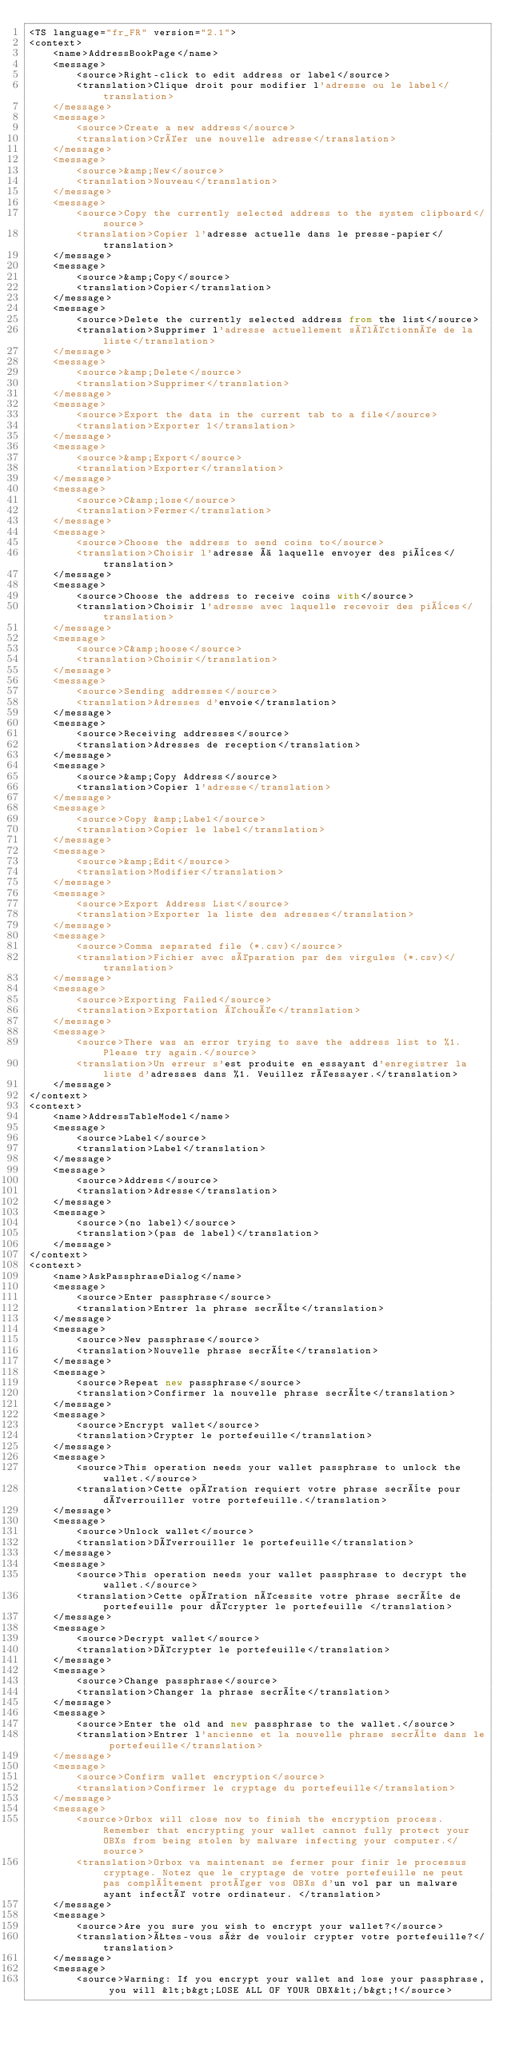<code> <loc_0><loc_0><loc_500><loc_500><_TypeScript_><TS language="fr_FR" version="2.1">
<context>
    <name>AddressBookPage</name>
    <message>
        <source>Right-click to edit address or label</source>
        <translation>Clique droit pour modifier l'adresse ou le label</translation>
    </message>
    <message>
        <source>Create a new address</source>
        <translation>Créer une nouvelle adresse</translation>
    </message>
    <message>
        <source>&amp;New</source>
        <translation>Nouveau</translation>
    </message>
    <message>
        <source>Copy the currently selected address to the system clipboard</source>
        <translation>Copier l'adresse actuelle dans le presse-papier</translation>
    </message>
    <message>
        <source>&amp;Copy</source>
        <translation>Copier</translation>
    </message>
    <message>
        <source>Delete the currently selected address from the list</source>
        <translation>Supprimer l'adresse actuellement séléctionnée de la liste</translation>
    </message>
    <message>
        <source>&amp;Delete</source>
        <translation>Supprimer</translation>
    </message>
    <message>
        <source>Export the data in the current tab to a file</source>
        <translation>Exporter l</translation>
    </message>
    <message>
        <source>&amp;Export</source>
        <translation>Exporter</translation>
    </message>
    <message>
        <source>C&amp;lose</source>
        <translation>Fermer</translation>
    </message>
    <message>
        <source>Choose the address to send coins to</source>
        <translation>Choisir l'adresse à laquelle envoyer des pièces</translation>
    </message>
    <message>
        <source>Choose the address to receive coins with</source>
        <translation>Choisir l'adresse avec laquelle recevoir des pièces</translation>
    </message>
    <message>
        <source>C&amp;hoose</source>
        <translation>Choisir</translation>
    </message>
    <message>
        <source>Sending addresses</source>
        <translation>Adresses d'envoie</translation>
    </message>
    <message>
        <source>Receiving addresses</source>
        <translation>Adresses de reception</translation>
    </message>
    <message>
        <source>&amp;Copy Address</source>
        <translation>Copier l'adresse</translation>
    </message>
    <message>
        <source>Copy &amp;Label</source>
        <translation>Copier le label</translation>
    </message>
    <message>
        <source>&amp;Edit</source>
        <translation>Modifier</translation>
    </message>
    <message>
        <source>Export Address List</source>
        <translation>Exporter la liste des adresses</translation>
    </message>
    <message>
        <source>Comma separated file (*.csv)</source>
        <translation>Fichier avec séparation par des virgules (*.csv)</translation>
    </message>
    <message>
        <source>Exporting Failed</source>
        <translation>Exportation échouée</translation>
    </message>
    <message>
        <source>There was an error trying to save the address list to %1. Please try again.</source>
        <translation>Un erreur s'est produite en essayant d'enregistrer la liste d'adresses dans %1. Veuillez réessayer.</translation>
    </message>
</context>
<context>
    <name>AddressTableModel</name>
    <message>
        <source>Label</source>
        <translation>Label</translation>
    </message>
    <message>
        <source>Address</source>
        <translation>Adresse</translation>
    </message>
    <message>
        <source>(no label)</source>
        <translation>(pas de label)</translation>
    </message>
</context>
<context>
    <name>AskPassphraseDialog</name>
    <message>
        <source>Enter passphrase</source>
        <translation>Entrer la phrase secrète</translation>
    </message>
    <message>
        <source>New passphrase</source>
        <translation>Nouvelle phrase secrète</translation>
    </message>
    <message>
        <source>Repeat new passphrase</source>
        <translation>Confirmer la nouvelle phrase secrète</translation>
    </message>
    <message>
        <source>Encrypt wallet</source>
        <translation>Crypter le portefeuille</translation>
    </message>
    <message>
        <source>This operation needs your wallet passphrase to unlock the wallet.</source>
        <translation>Cette opération requiert votre phrase secrète pour déverrouiller votre portefeuille.</translation>
    </message>
    <message>
        <source>Unlock wallet</source>
        <translation>Déverrouiller le portefeuille</translation>
    </message>
    <message>
        <source>This operation needs your wallet passphrase to decrypt the wallet.</source>
        <translation>Cette opération nécessite votre phrase secrète de portefeuille pour décrypter le portefeuille </translation>
    </message>
    <message>
        <source>Decrypt wallet</source>
        <translation>Décrypter le portefeuille</translation>
    </message>
    <message>
        <source>Change passphrase</source>
        <translation>Changer la phrase secrète</translation>
    </message>
    <message>
        <source>Enter the old and new passphrase to the wallet.</source>
        <translation>Entrer l'ancienne et la nouvelle phrase secrète dans le portefeuille</translation>
    </message>
    <message>
        <source>Confirm wallet encryption</source>
        <translation>Confirmer le cryptage du portefeuille</translation>
    </message>
    <message>
        <source>Orbox will close now to finish the encryption process. Remember that encrypting your wallet cannot fully protect your OBXs from being stolen by malware infecting your computer.</source>
        <translation>Orbox va maintenant se fermer pour finir le processus cryptage. Notez que le cryptage de votre portefeuille ne peut pas complètement protéger vos OBXs d'un vol par un malware ayant infecté votre ordinateur. </translation>
    </message>
    <message>
        <source>Are you sure you wish to encrypt your wallet?</source>
        <translation>Êtes-vous sûr de vouloir crypter votre portefeuille?</translation>
    </message>
    <message>
        <source>Warning: If you encrypt your wallet and lose your passphrase, you will &lt;b&gt;LOSE ALL OF YOUR OBX&lt;/b&gt;!</source></code> 